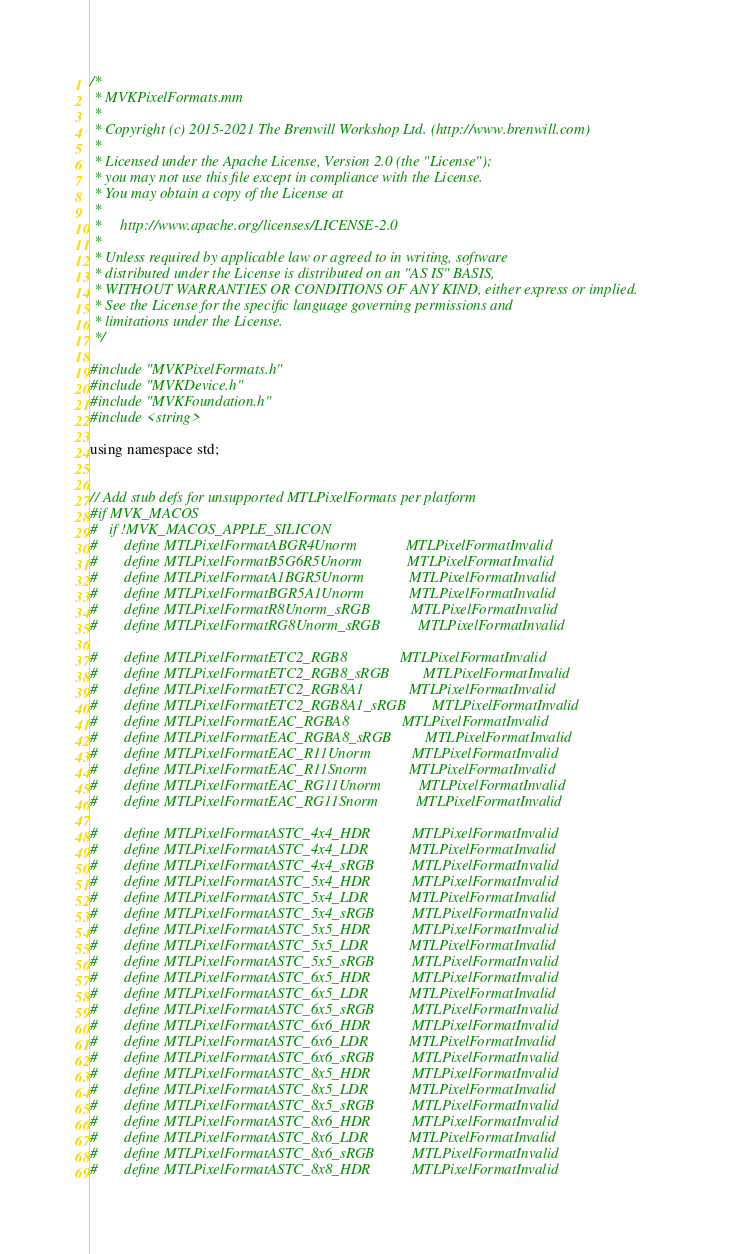<code> <loc_0><loc_0><loc_500><loc_500><_ObjectiveC_>/*
 * MVKPixelFormats.mm
 *
 * Copyright (c) 2015-2021 The Brenwill Workshop Ltd. (http://www.brenwill.com)
 *
 * Licensed under the Apache License, Version 2.0 (the "License");
 * you may not use this file except in compliance with the License.
 * You may obtain a copy of the License at
 *
 *     http://www.apache.org/licenses/LICENSE-2.0
 *
 * Unless required by applicable law or agreed to in writing, software
 * distributed under the License is distributed on an "AS IS" BASIS,
 * WITHOUT WARRANTIES OR CONDITIONS OF ANY KIND, either express or implied.
 * See the License for the specific language governing permissions and
 * limitations under the License.
 */

#include "MVKPixelFormats.h"
#include "MVKDevice.h"
#include "MVKFoundation.h"
#include <string>

using namespace std;


// Add stub defs for unsupported MTLPixelFormats per platform
#if MVK_MACOS
#   if !MVK_MACOS_APPLE_SILICON
#       define MTLPixelFormatABGR4Unorm             MTLPixelFormatInvalid
#       define MTLPixelFormatB5G6R5Unorm            MTLPixelFormatInvalid
#       define MTLPixelFormatA1BGR5Unorm            MTLPixelFormatInvalid
#       define MTLPixelFormatBGR5A1Unorm            MTLPixelFormatInvalid
#       define MTLPixelFormatR8Unorm_sRGB           MTLPixelFormatInvalid
#       define MTLPixelFormatRG8Unorm_sRGB          MTLPixelFormatInvalid

#       define MTLPixelFormatETC2_RGB8              MTLPixelFormatInvalid
#       define MTLPixelFormatETC2_RGB8_sRGB         MTLPixelFormatInvalid
#       define MTLPixelFormatETC2_RGB8A1            MTLPixelFormatInvalid
#       define MTLPixelFormatETC2_RGB8A1_sRGB       MTLPixelFormatInvalid
#       define MTLPixelFormatEAC_RGBA8              MTLPixelFormatInvalid
#       define MTLPixelFormatEAC_RGBA8_sRGB         MTLPixelFormatInvalid
#       define MTLPixelFormatEAC_R11Unorm           MTLPixelFormatInvalid
#       define MTLPixelFormatEAC_R11Snorm           MTLPixelFormatInvalid
#       define MTLPixelFormatEAC_RG11Unorm          MTLPixelFormatInvalid
#       define MTLPixelFormatEAC_RG11Snorm          MTLPixelFormatInvalid

#       define MTLPixelFormatASTC_4x4_HDR           MTLPixelFormatInvalid
#       define MTLPixelFormatASTC_4x4_LDR           MTLPixelFormatInvalid
#       define MTLPixelFormatASTC_4x4_sRGB          MTLPixelFormatInvalid
#       define MTLPixelFormatASTC_5x4_HDR           MTLPixelFormatInvalid
#       define MTLPixelFormatASTC_5x4_LDR           MTLPixelFormatInvalid
#       define MTLPixelFormatASTC_5x4_sRGB          MTLPixelFormatInvalid
#       define MTLPixelFormatASTC_5x5_HDR           MTLPixelFormatInvalid
#       define MTLPixelFormatASTC_5x5_LDR           MTLPixelFormatInvalid
#       define MTLPixelFormatASTC_5x5_sRGB          MTLPixelFormatInvalid
#       define MTLPixelFormatASTC_6x5_HDR           MTLPixelFormatInvalid
#       define MTLPixelFormatASTC_6x5_LDR           MTLPixelFormatInvalid
#       define MTLPixelFormatASTC_6x5_sRGB          MTLPixelFormatInvalid
#       define MTLPixelFormatASTC_6x6_HDR           MTLPixelFormatInvalid
#       define MTLPixelFormatASTC_6x6_LDR           MTLPixelFormatInvalid
#       define MTLPixelFormatASTC_6x6_sRGB          MTLPixelFormatInvalid
#       define MTLPixelFormatASTC_8x5_HDR           MTLPixelFormatInvalid
#       define MTLPixelFormatASTC_8x5_LDR           MTLPixelFormatInvalid
#       define MTLPixelFormatASTC_8x5_sRGB          MTLPixelFormatInvalid
#       define MTLPixelFormatASTC_8x6_HDR           MTLPixelFormatInvalid
#       define MTLPixelFormatASTC_8x6_LDR           MTLPixelFormatInvalid
#       define MTLPixelFormatASTC_8x6_sRGB          MTLPixelFormatInvalid
#       define MTLPixelFormatASTC_8x8_HDR           MTLPixelFormatInvalid</code> 